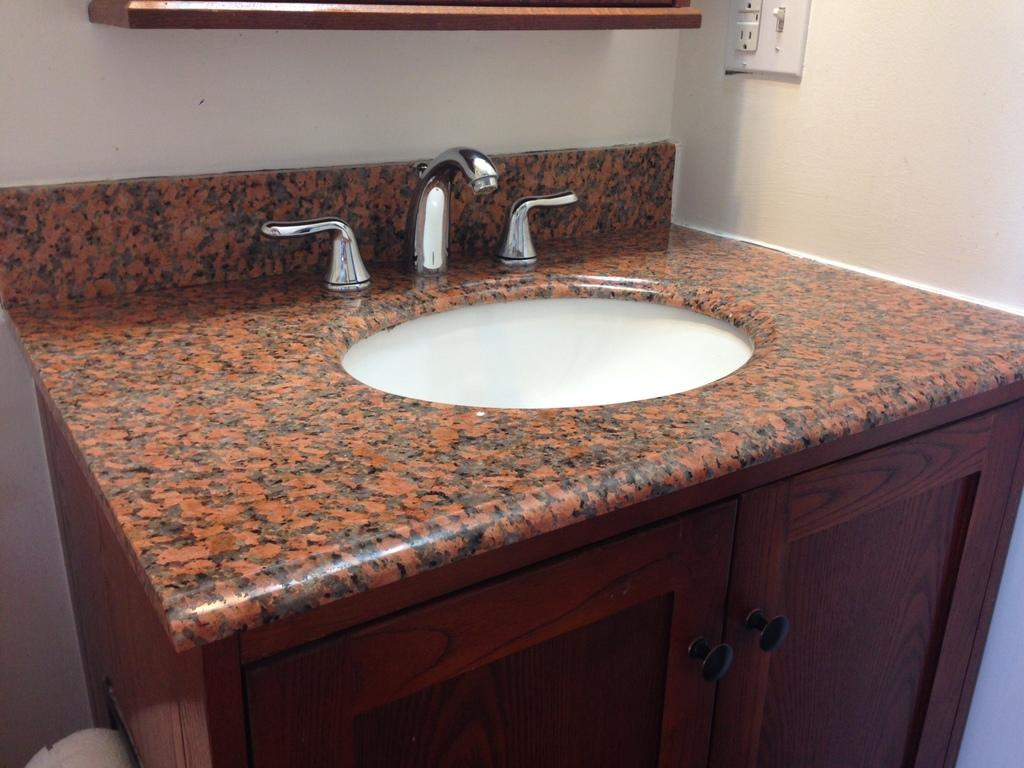What is the color of the cabinet in the image? The cabinet in the image is brown colored. What is located near the cabinet in the image? There is a sink in the image. What can be used to control the flow of water in the sink? There is a tap in the image. What is visible on the wall in the image? The wall is visible in the image, and there is a switch board attached to it. What is the color of the object at the top of the image? There is a brown colored object at the top of the image. How does the scale help in comparing the size of the objects in the image? There is no scale present in the image, so it cannot be used to compare the size of the objects. 